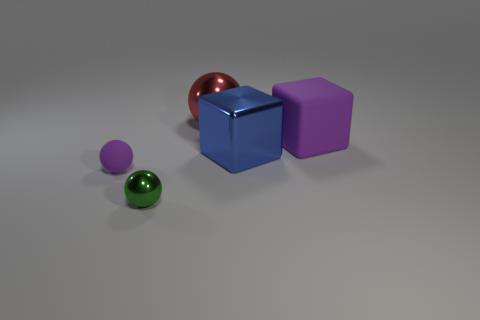What can you infer about the surface on which the objects are placed? The surface appears to be smooth and even, with a matte texture that softens reflections. Its neutrality in color suggests it was chosen to emphasize the colors and shapes of the objects placed upon it. 